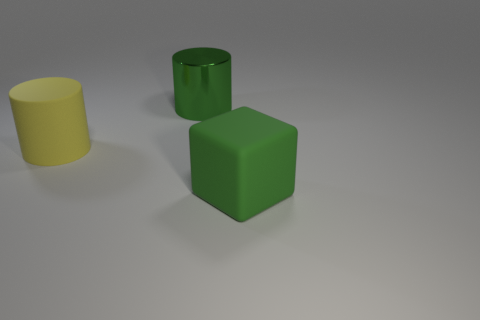Add 3 rubber blocks. How many objects exist? 6 Subtract all green cylinders. How many cylinders are left? 1 Subtract all cylinders. How many objects are left? 1 Subtract all yellow cylinders. Subtract all gray balls. How many cylinders are left? 1 Subtract all red cylinders. How many yellow blocks are left? 0 Subtract all green cylinders. Subtract all yellow rubber cylinders. How many objects are left? 1 Add 1 yellow objects. How many yellow objects are left? 2 Add 1 cylinders. How many cylinders exist? 3 Subtract 0 blue cubes. How many objects are left? 3 Subtract 1 cubes. How many cubes are left? 0 